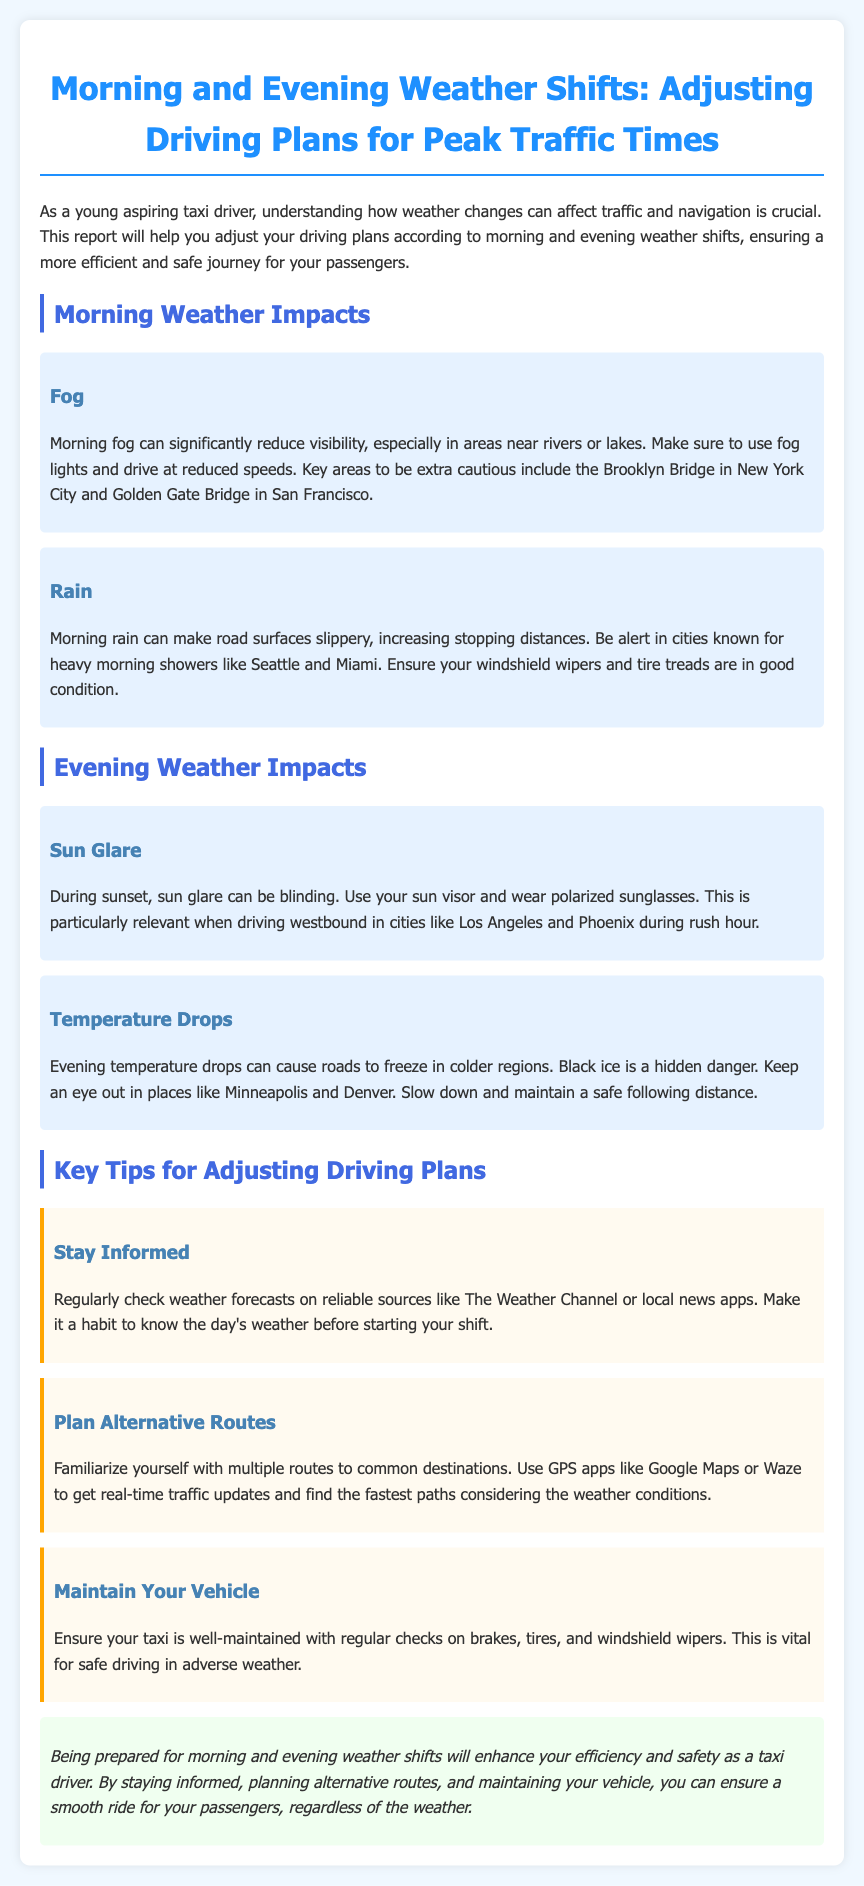what are two weather impacts in the morning? The document lists fog and rain as the two weather impacts in the morning.
Answer: fog, rain where should you be cautious during morning fog? The document mentions the Brooklyn Bridge and Golden Gate Bridge are key areas to be cautious during morning fog.
Answer: Brooklyn Bridge, Golden Gate Bridge what should you maintain for safe driving in rain? The document emphasizes the condition of windshield wipers and tire treads for safe driving in rain.
Answer: windshield wipers, tire treads what is a danger related to evening temperature drops? The document states that evening temperature drops can cause black ice, which is a hidden danger.
Answer: black ice which two cities are mentioned for sun glare during evening? The document lists Los Angeles and Phoenix as cities where sun glare is a concern during the evening.
Answer: Los Angeles, Phoenix what is the recommended tool for checking weather forecasts? The document suggests checking weather forecasts on reliable sources like The Weather Channel or local news apps.
Answer: The Weather Channel what is a key tip for alternative routes? The document advises familiarizing yourself with multiple routes to common destinations.
Answer: multiple routes how can you enhance your efficiency as a taxi driver? The conclusion states that being prepared for morning and evening weather shifts will enhance your efficiency.
Answer: being prepared 